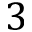Convert formula to latex. <formula><loc_0><loc_0><loc_500><loc_500>3</formula> 